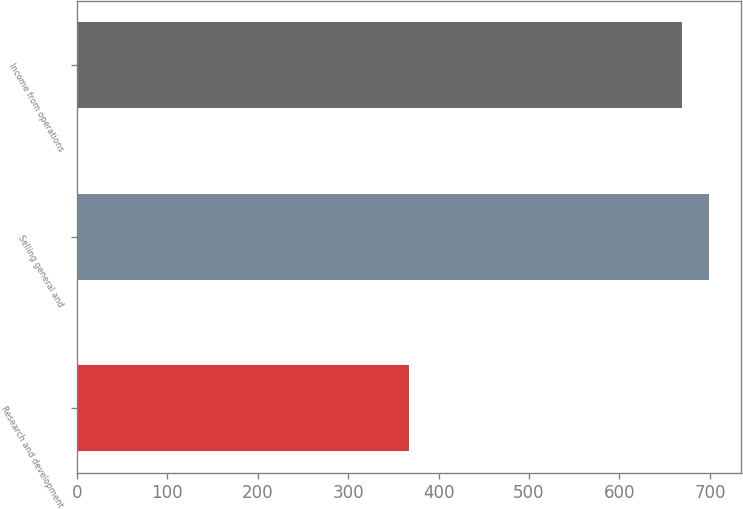Convert chart. <chart><loc_0><loc_0><loc_500><loc_500><bar_chart><fcel>Research and development<fcel>Selling general and<fcel>Income from operations<nl><fcel>367<fcel>699.5<fcel>669<nl></chart> 